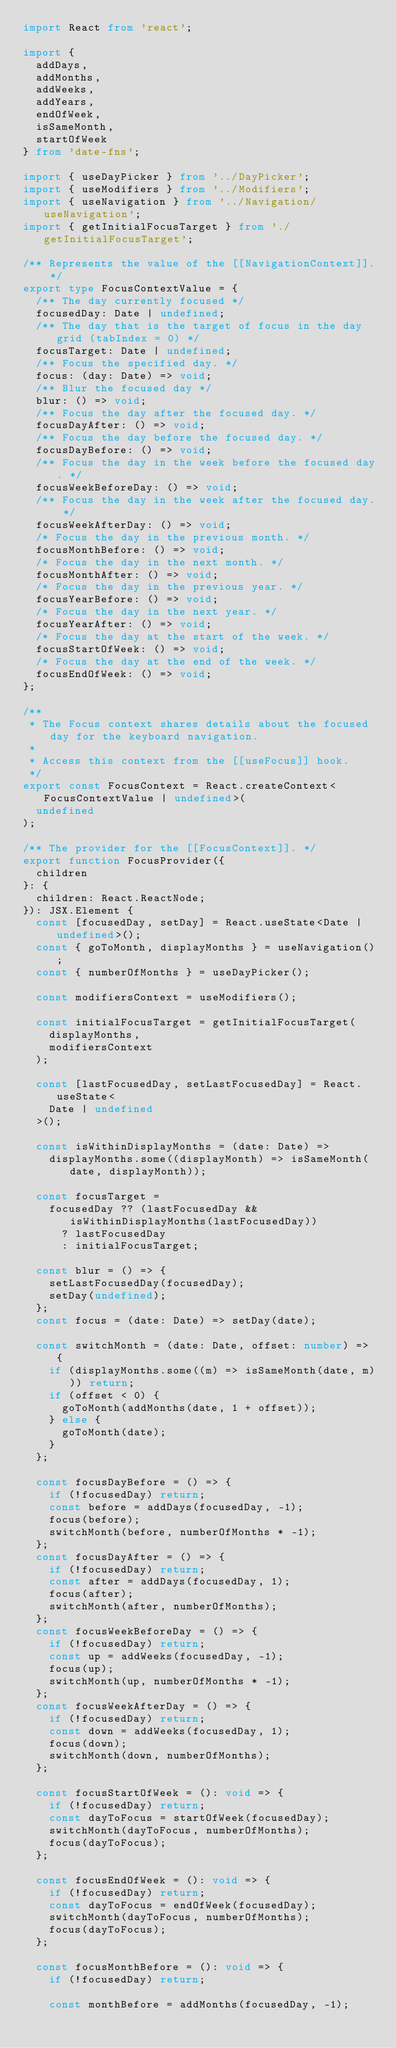<code> <loc_0><loc_0><loc_500><loc_500><_TypeScript_>import React from 'react';

import {
  addDays,
  addMonths,
  addWeeks,
  addYears,
  endOfWeek,
  isSameMonth,
  startOfWeek
} from 'date-fns';

import { useDayPicker } from '../DayPicker';
import { useModifiers } from '../Modifiers';
import { useNavigation } from '../Navigation/useNavigation';
import { getInitialFocusTarget } from './getInitialFocusTarget';

/** Represents the value of the [[NavigationContext]]. */
export type FocusContextValue = {
  /** The day currently focused */
  focusedDay: Date | undefined;
  /** The day that is the target of focus in the day grid (tabIndex = 0) */
  focusTarget: Date | undefined;
  /** Focus the specified day. */
  focus: (day: Date) => void;
  /** Blur the focused day */
  blur: () => void;
  /** Focus the day after the focused day. */
  focusDayAfter: () => void;
  /** Focus the day before the focused day. */
  focusDayBefore: () => void;
  /** Focus the day in the week before the focused day. */
  focusWeekBeforeDay: () => void;
  /** Focus the day in the week after the focused day. */
  focusWeekAfterDay: () => void;
  /* Focus the day in the previous month. */
  focusMonthBefore: () => void;
  /* Focus the day in the next month. */
  focusMonthAfter: () => void;
  /* Focus the day in the previous year. */
  focusYearBefore: () => void;
  /* Focus the day in the next year. */
  focusYearAfter: () => void;
  /* Focus the day at the start of the week. */
  focusStartOfWeek: () => void;
  /* Focus the day at the end of the week. */
  focusEndOfWeek: () => void;
};

/**
 * The Focus context shares details about the focused day for the keyboard navigation.
 *
 * Access this context from the [[useFocus]] hook.
 */
export const FocusContext = React.createContext<FocusContextValue | undefined>(
  undefined
);

/** The provider for the [[FocusContext]]. */
export function FocusProvider({
  children
}: {
  children: React.ReactNode;
}): JSX.Element {
  const [focusedDay, setDay] = React.useState<Date | undefined>();
  const { goToMonth, displayMonths } = useNavigation();
  const { numberOfMonths } = useDayPicker();

  const modifiersContext = useModifiers();

  const initialFocusTarget = getInitialFocusTarget(
    displayMonths,
    modifiersContext
  );

  const [lastFocusedDay, setLastFocusedDay] = React.useState<
    Date | undefined
  >();

  const isWithinDisplayMonths = (date: Date) =>
    displayMonths.some((displayMonth) => isSameMonth(date, displayMonth));

  const focusTarget =
    focusedDay ?? (lastFocusedDay && isWithinDisplayMonths(lastFocusedDay))
      ? lastFocusedDay
      : initialFocusTarget;

  const blur = () => {
    setLastFocusedDay(focusedDay);
    setDay(undefined);
  };
  const focus = (date: Date) => setDay(date);

  const switchMonth = (date: Date, offset: number) => {
    if (displayMonths.some((m) => isSameMonth(date, m))) return;
    if (offset < 0) {
      goToMonth(addMonths(date, 1 + offset));
    } else {
      goToMonth(date);
    }
  };

  const focusDayBefore = () => {
    if (!focusedDay) return;
    const before = addDays(focusedDay, -1);
    focus(before);
    switchMonth(before, numberOfMonths * -1);
  };
  const focusDayAfter = () => {
    if (!focusedDay) return;
    const after = addDays(focusedDay, 1);
    focus(after);
    switchMonth(after, numberOfMonths);
  };
  const focusWeekBeforeDay = () => {
    if (!focusedDay) return;
    const up = addWeeks(focusedDay, -1);
    focus(up);
    switchMonth(up, numberOfMonths * -1);
  };
  const focusWeekAfterDay = () => {
    if (!focusedDay) return;
    const down = addWeeks(focusedDay, 1);
    focus(down);
    switchMonth(down, numberOfMonths);
  };

  const focusStartOfWeek = (): void => {
    if (!focusedDay) return;
    const dayToFocus = startOfWeek(focusedDay);
    switchMonth(dayToFocus, numberOfMonths);
    focus(dayToFocus);
  };

  const focusEndOfWeek = (): void => {
    if (!focusedDay) return;
    const dayToFocus = endOfWeek(focusedDay);
    switchMonth(dayToFocus, numberOfMonths);
    focus(dayToFocus);
  };

  const focusMonthBefore = (): void => {
    if (!focusedDay) return;

    const monthBefore = addMonths(focusedDay, -1);</code> 